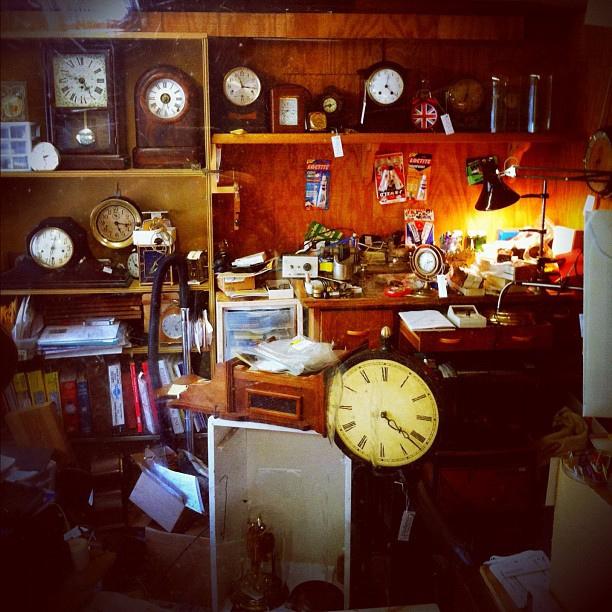Is most of the stuff in this room old or new?
Be succinct. Old. What is the picture in the bright yellow clock?
Short answer required. None. Do all the clocks show the same time?
Keep it brief. No. How many clocks are in this picture?
Write a very short answer. 17. 